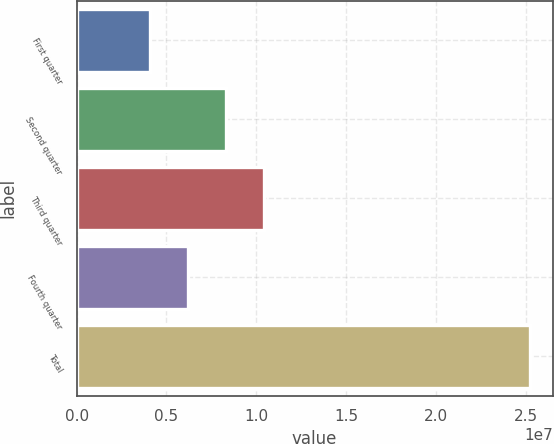Convert chart. <chart><loc_0><loc_0><loc_500><loc_500><bar_chart><fcel>First quarter<fcel>Second quarter<fcel>Third quarter<fcel>Fourth quarter<fcel>Total<nl><fcel>4.088e+06<fcel>8.31981e+06<fcel>1.04357e+07<fcel>6.2039e+06<fcel>2.5247e+07<nl></chart> 